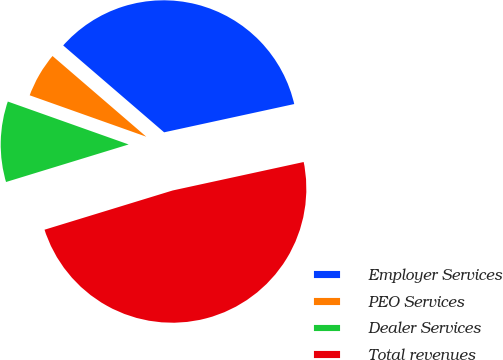Convert chart to OTSL. <chart><loc_0><loc_0><loc_500><loc_500><pie_chart><fcel>Employer Services<fcel>PEO Services<fcel>Dealer Services<fcel>Total revenues<nl><fcel>35.28%<fcel>5.88%<fcel>10.16%<fcel>48.67%<nl></chart> 